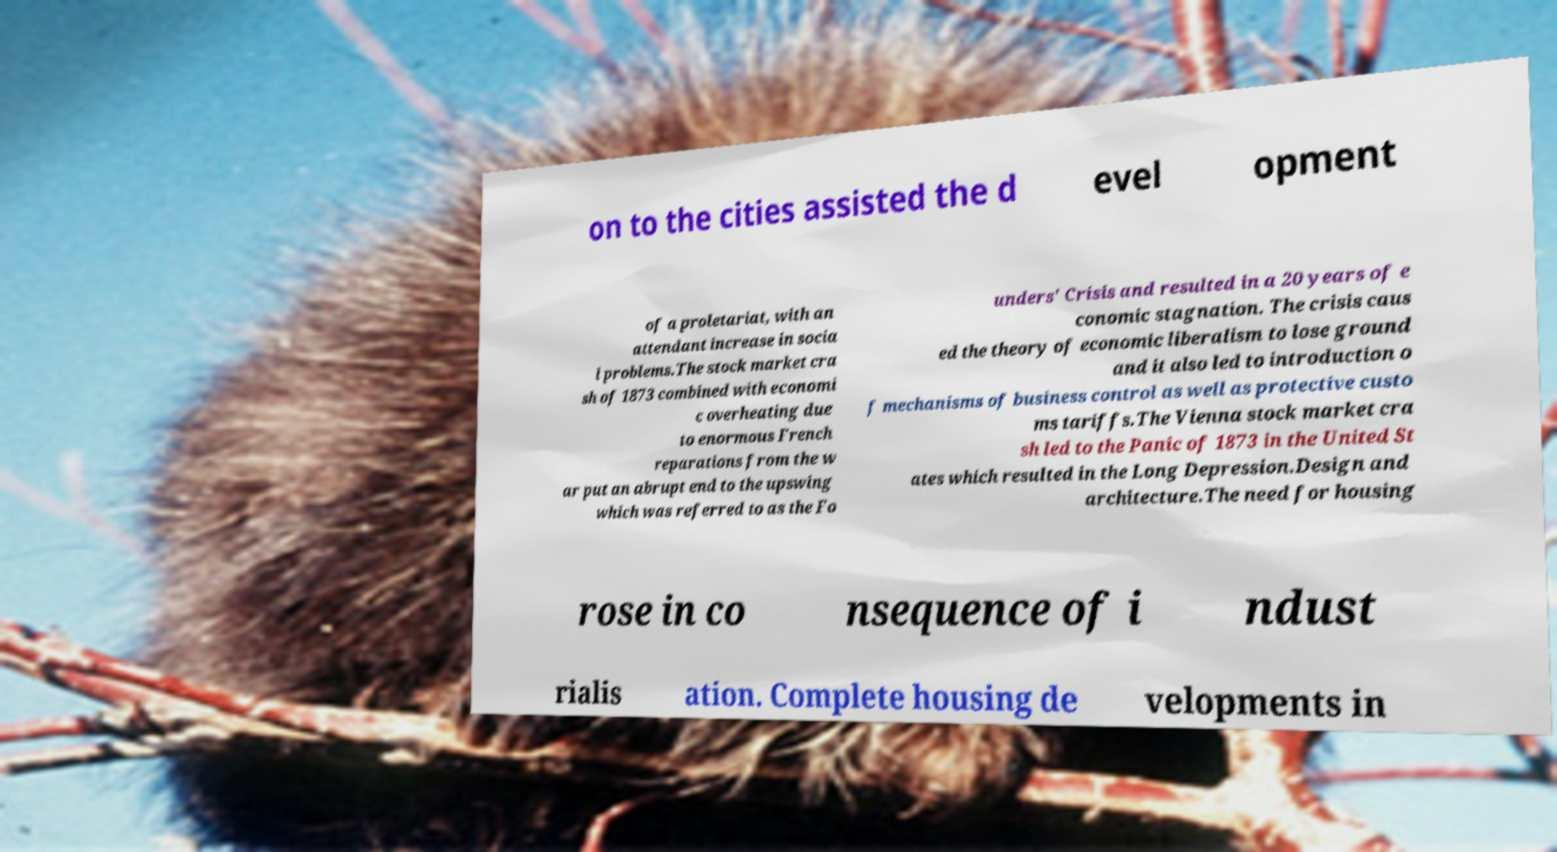Please identify and transcribe the text found in this image. on to the cities assisted the d evel opment of a proletariat, with an attendant increase in socia l problems.The stock market cra sh of 1873 combined with economi c overheating due to enormous French reparations from the w ar put an abrupt end to the upswing which was referred to as the Fo unders' Crisis and resulted in a 20 years of e conomic stagnation. The crisis caus ed the theory of economic liberalism to lose ground and it also led to introduction o f mechanisms of business control as well as protective custo ms tariffs.The Vienna stock market cra sh led to the Panic of 1873 in the United St ates which resulted in the Long Depression.Design and architecture.The need for housing rose in co nsequence of i ndust rialis ation. Complete housing de velopments in 